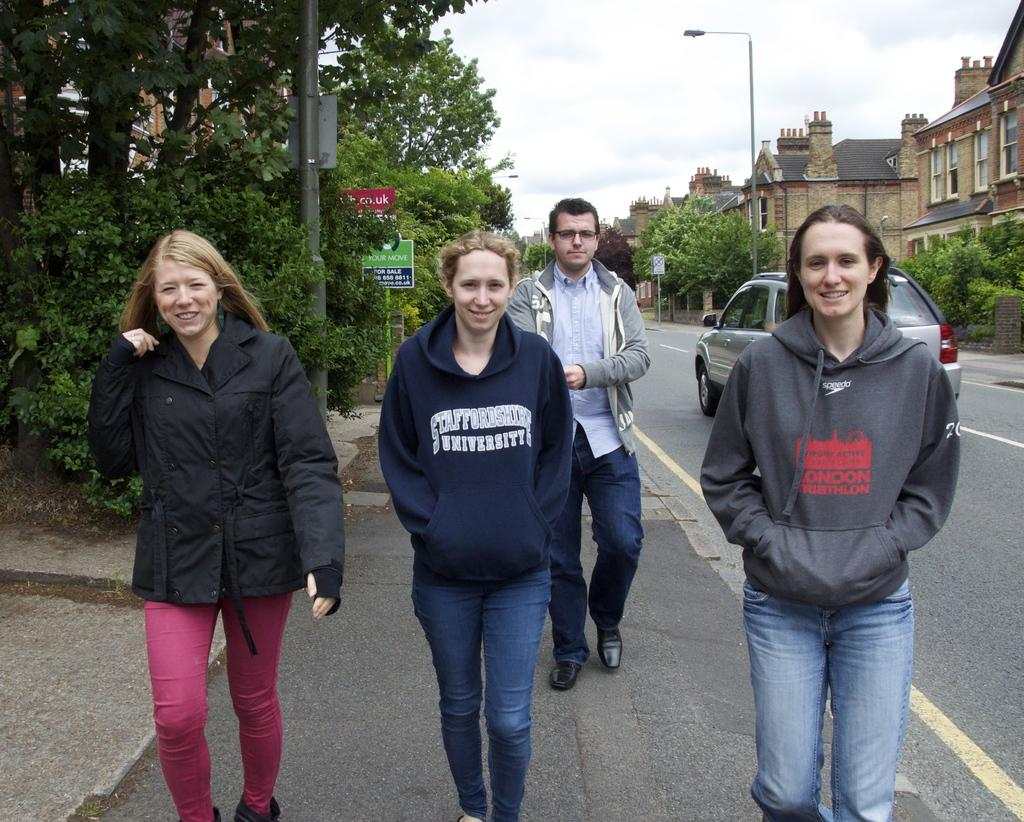What is happening on the road in the image? There are persons on the road in the image. What else can be seen on the road in the background? There is a vehicle on the road in the background. What can be seen in the background of the image? There are trees, boards on a pole, buildings, windows, and clouds in the sky visible in the background. What type of plastic is being used to make the whip in the image? There is no whip present in the image. How many umbrellas are being held by the persons on the road in the image? There is no mention of umbrellas in the image; the persons on the road do not appear to be holding any. 